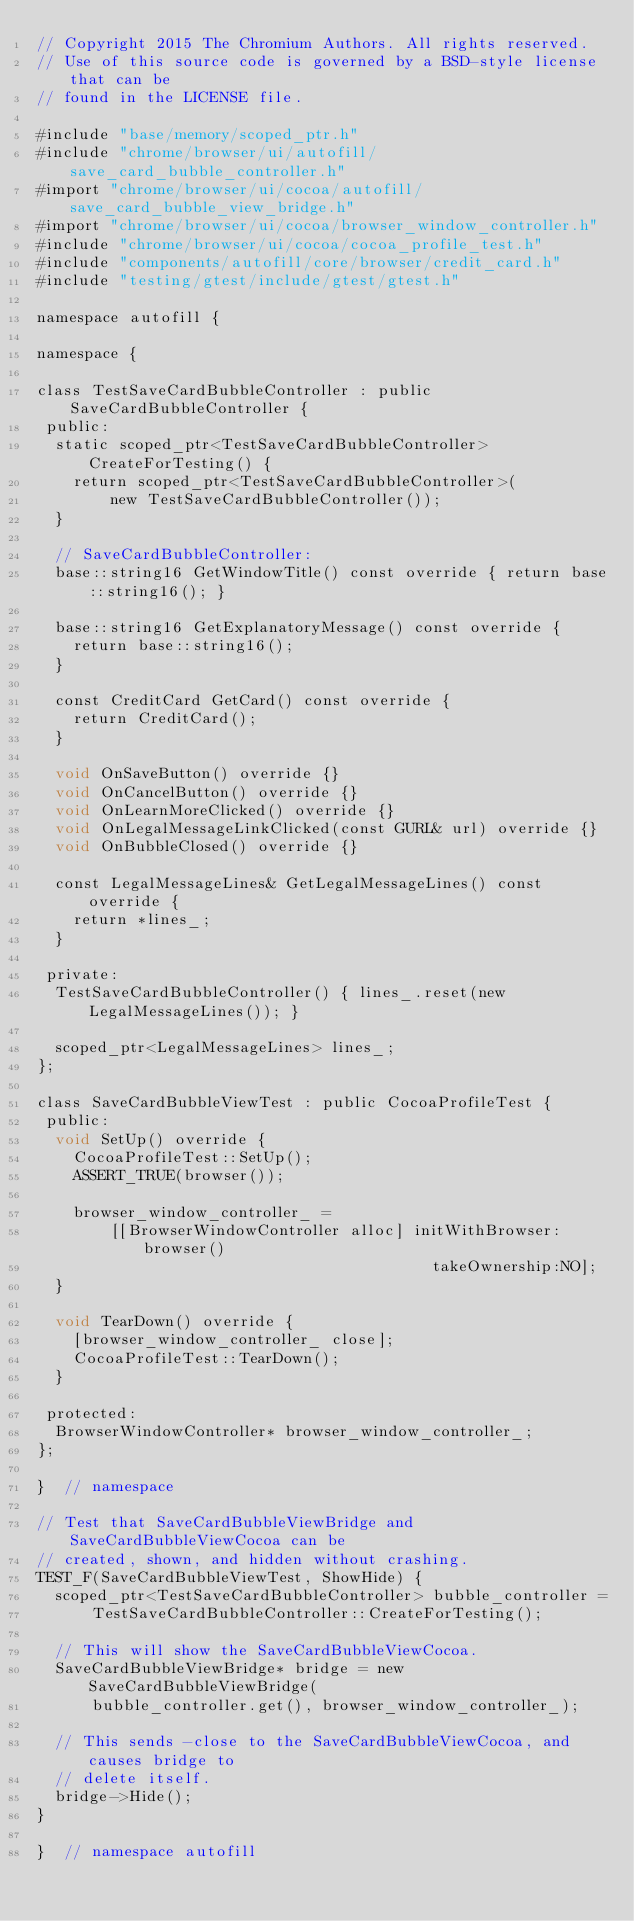Convert code to text. <code><loc_0><loc_0><loc_500><loc_500><_ObjectiveC_>// Copyright 2015 The Chromium Authors. All rights reserved.
// Use of this source code is governed by a BSD-style license that can be
// found in the LICENSE file.

#include "base/memory/scoped_ptr.h"
#include "chrome/browser/ui/autofill/save_card_bubble_controller.h"
#import "chrome/browser/ui/cocoa/autofill/save_card_bubble_view_bridge.h"
#import "chrome/browser/ui/cocoa/browser_window_controller.h"
#include "chrome/browser/ui/cocoa/cocoa_profile_test.h"
#include "components/autofill/core/browser/credit_card.h"
#include "testing/gtest/include/gtest/gtest.h"

namespace autofill {

namespace {

class TestSaveCardBubbleController : public SaveCardBubbleController {
 public:
  static scoped_ptr<TestSaveCardBubbleController> CreateForTesting() {
    return scoped_ptr<TestSaveCardBubbleController>(
        new TestSaveCardBubbleController());
  }

  // SaveCardBubbleController:
  base::string16 GetWindowTitle() const override { return base::string16(); }

  base::string16 GetExplanatoryMessage() const override {
    return base::string16();
  }

  const CreditCard GetCard() const override {
    return CreditCard();
  }

  void OnSaveButton() override {}
  void OnCancelButton() override {}
  void OnLearnMoreClicked() override {}
  void OnLegalMessageLinkClicked(const GURL& url) override {}
  void OnBubbleClosed() override {}

  const LegalMessageLines& GetLegalMessageLines() const override {
    return *lines_;
  }

 private:
  TestSaveCardBubbleController() { lines_.reset(new LegalMessageLines()); }

  scoped_ptr<LegalMessageLines> lines_;
};

class SaveCardBubbleViewTest : public CocoaProfileTest {
 public:
  void SetUp() override {
    CocoaProfileTest::SetUp();
    ASSERT_TRUE(browser());

    browser_window_controller_ =
        [[BrowserWindowController alloc] initWithBrowser:browser()
                                           takeOwnership:NO];
  }

  void TearDown() override {
    [browser_window_controller_ close];
    CocoaProfileTest::TearDown();
  }

 protected:
  BrowserWindowController* browser_window_controller_;
};

}  // namespace

// Test that SaveCardBubbleViewBridge and SaveCardBubbleViewCocoa can be
// created, shown, and hidden without crashing.
TEST_F(SaveCardBubbleViewTest, ShowHide) {
  scoped_ptr<TestSaveCardBubbleController> bubble_controller =
      TestSaveCardBubbleController::CreateForTesting();

  // This will show the SaveCardBubbleViewCocoa.
  SaveCardBubbleViewBridge* bridge = new SaveCardBubbleViewBridge(
      bubble_controller.get(), browser_window_controller_);

  // This sends -close to the SaveCardBubbleViewCocoa, and causes bridge to
  // delete itself.
  bridge->Hide();
}

}  // namespace autofill
</code> 